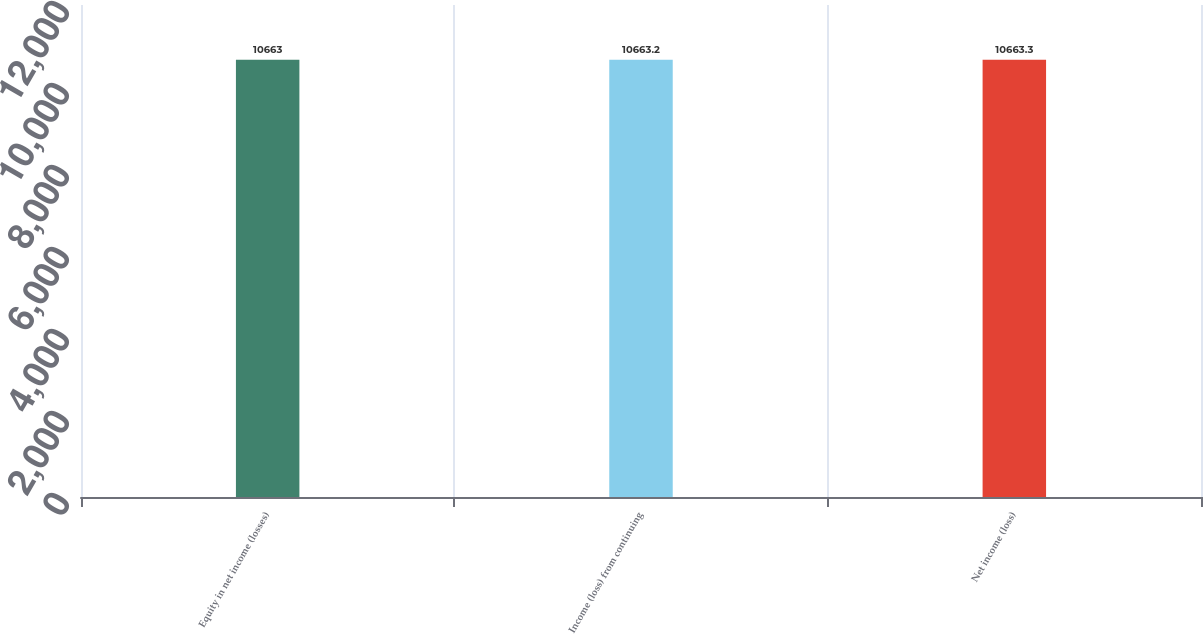Convert chart. <chart><loc_0><loc_0><loc_500><loc_500><bar_chart><fcel>Equity in net income (losses)<fcel>Income (loss) from continuing<fcel>Net income (loss)<nl><fcel>10663<fcel>10663.2<fcel>10663.3<nl></chart> 